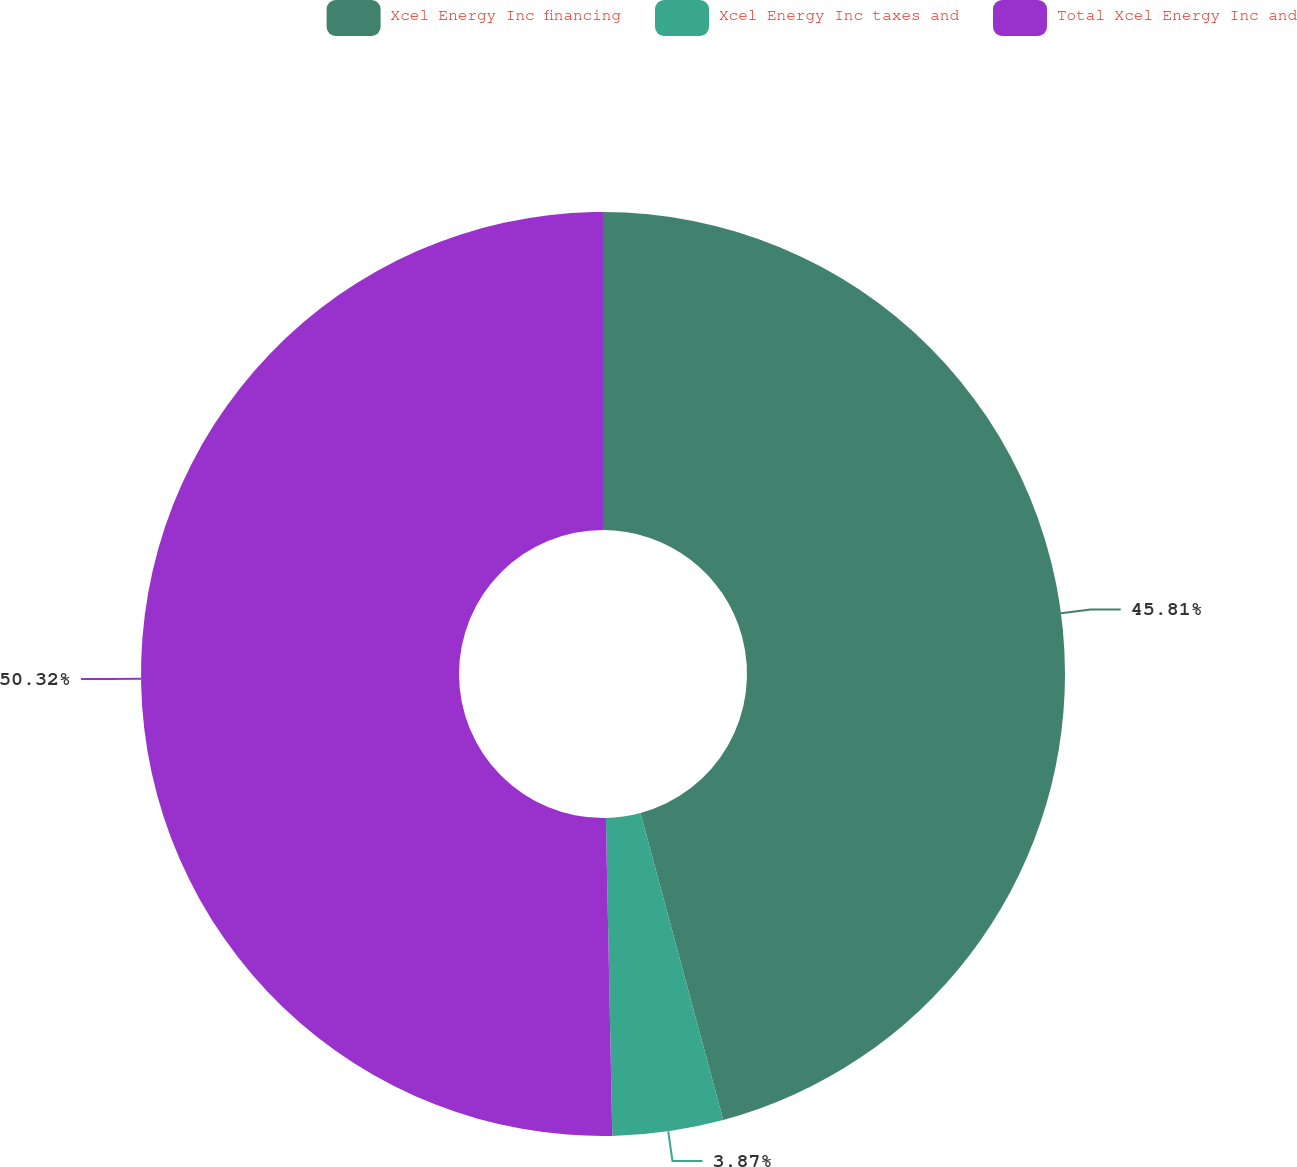Convert chart. <chart><loc_0><loc_0><loc_500><loc_500><pie_chart><fcel>Xcel Energy Inc financing<fcel>Xcel Energy Inc taxes and<fcel>Total Xcel Energy Inc and<nl><fcel>45.81%<fcel>3.87%<fcel>50.32%<nl></chart> 